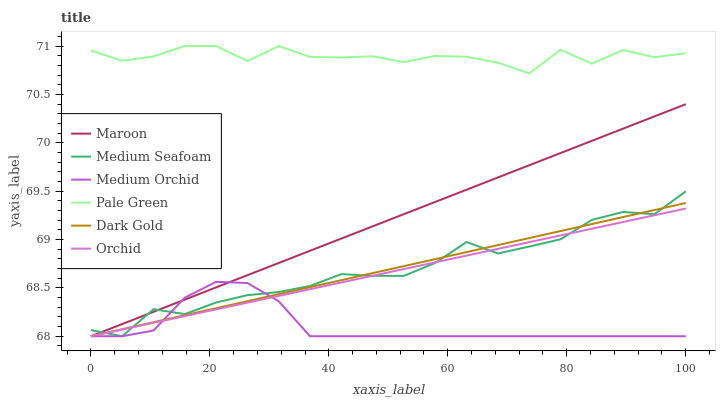Does Medium Orchid have the minimum area under the curve?
Answer yes or no. Yes. Does Pale Green have the maximum area under the curve?
Answer yes or no. Yes. Does Maroon have the minimum area under the curve?
Answer yes or no. No. Does Maroon have the maximum area under the curve?
Answer yes or no. No. Is Maroon the smoothest?
Answer yes or no. Yes. Is Pale Green the roughest?
Answer yes or no. Yes. Is Medium Orchid the smoothest?
Answer yes or no. No. Is Medium Orchid the roughest?
Answer yes or no. No. Does Dark Gold have the lowest value?
Answer yes or no. Yes. Does Pale Green have the lowest value?
Answer yes or no. No. Does Pale Green have the highest value?
Answer yes or no. Yes. Does Maroon have the highest value?
Answer yes or no. No. Is Medium Orchid less than Pale Green?
Answer yes or no. Yes. Is Pale Green greater than Medium Seafoam?
Answer yes or no. Yes. Does Medium Seafoam intersect Dark Gold?
Answer yes or no. Yes. Is Medium Seafoam less than Dark Gold?
Answer yes or no. No. Is Medium Seafoam greater than Dark Gold?
Answer yes or no. No. Does Medium Orchid intersect Pale Green?
Answer yes or no. No. 